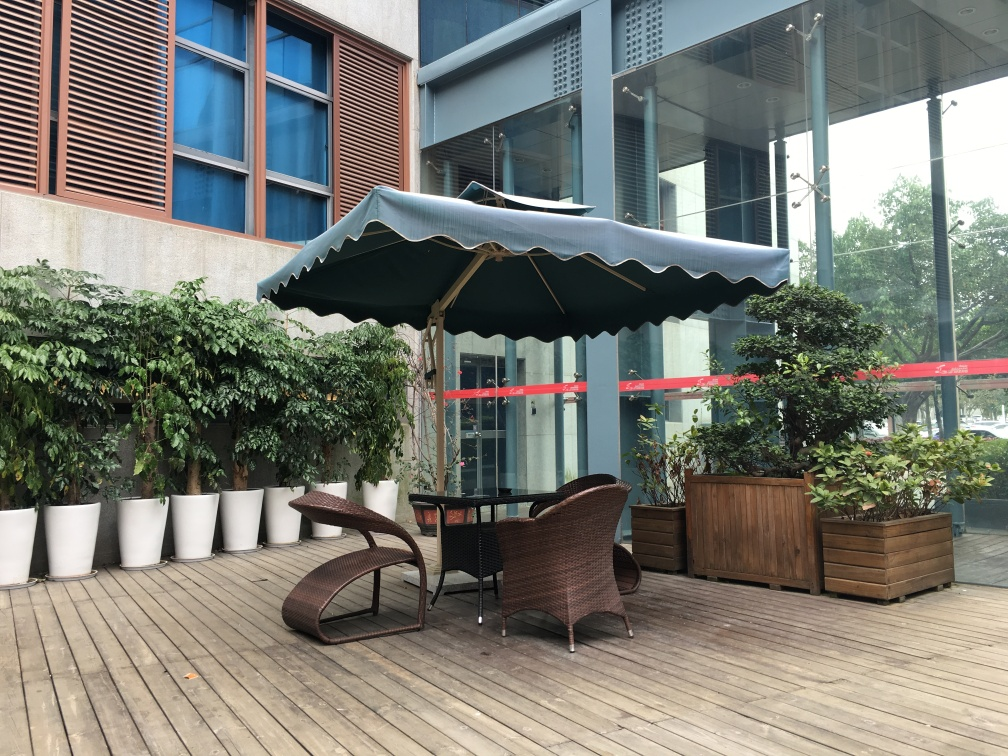Does this outdoor space seem to be part of a commercial or residential area? This outdoor space, with its large glass windows reflecting an urban environment and a protective barrier tape suggesting temporary restrictions, seems to be part of a commercial area, likely associated with a café or restaurant where patrons can enjoy an open-air setting. What kind of weather conditions does the umbrella suggest this area is prepared for? The presence of a sturdy, large umbrella implies that this area is equipped to handle sunny weather conditions, offering shade to those seated underneath. The construction of the umbrella also suggests it could provide protection during light rain, ensuring the space remains functional despite changing weather. 